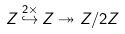Convert formula to latex. <formula><loc_0><loc_0><loc_500><loc_500>Z \, { \overset { 2 \times } { \hookrightarrow } } \, Z \twoheadrightarrow Z / 2 Z</formula> 